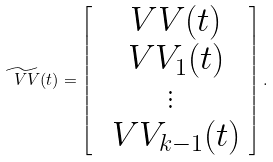Convert formula to latex. <formula><loc_0><loc_0><loc_500><loc_500>\widetilde { \ V V } ( t ) = \left [ \begin{array} { c } \ V V ( t ) \\ \ V V _ { 1 } ( t ) \\ \vdots \\ \ V V _ { k - 1 } ( t ) \end{array} \right ] .</formula> 